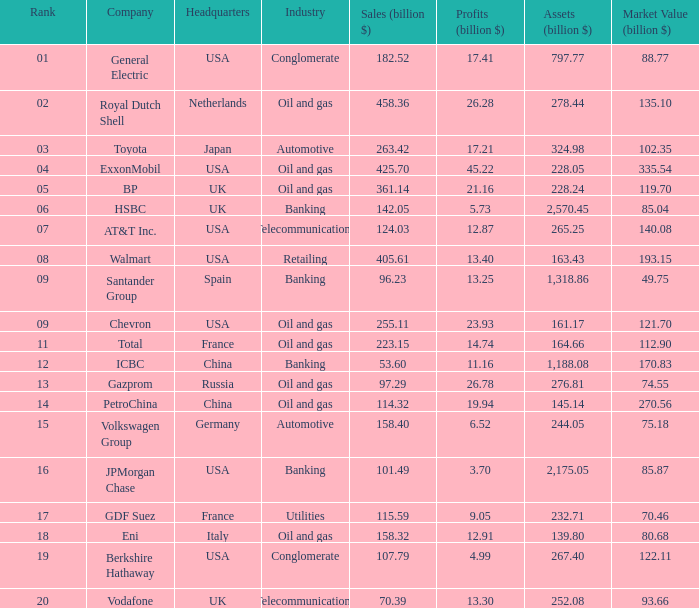Parse the full table. {'header': ['Rank', 'Company', 'Headquarters', 'Industry', 'Sales (billion $)', 'Profits (billion $)', 'Assets (billion $)', 'Market Value (billion $)'], 'rows': [['01', 'General Electric', 'USA', 'Conglomerate', '182.52', '17.41', '797.77', '88.77'], ['02', 'Royal Dutch Shell', 'Netherlands', 'Oil and gas', '458.36', '26.28', '278.44', '135.10'], ['03', 'Toyota', 'Japan', 'Automotive', '263.42', '17.21', '324.98', '102.35'], ['04', 'ExxonMobil', 'USA', 'Oil and gas', '425.70', '45.22', '228.05', '335.54'], ['05', 'BP', 'UK', 'Oil and gas', '361.14', '21.16', '228.24', '119.70'], ['06', 'HSBC', 'UK', 'Banking', '142.05', '5.73', '2,570.45', '85.04'], ['07', 'AT&T Inc.', 'USA', 'Telecommunications', '124.03', '12.87', '265.25', '140.08'], ['08', 'Walmart', 'USA', 'Retailing', '405.61', '13.40', '163.43', '193.15'], ['09', 'Santander Group', 'Spain', 'Banking', '96.23', '13.25', '1,318.86', '49.75'], ['09', 'Chevron', 'USA', 'Oil and gas', '255.11', '23.93', '161.17', '121.70'], ['11', 'Total', 'France', 'Oil and gas', '223.15', '14.74', '164.66', '112.90'], ['12', 'ICBC', 'China', 'Banking', '53.60', '11.16', '1,188.08', '170.83'], ['13', 'Gazprom', 'Russia', 'Oil and gas', '97.29', '26.78', '276.81', '74.55'], ['14', 'PetroChina', 'China', 'Oil and gas', '114.32', '19.94', '145.14', '270.56'], ['15', 'Volkswagen Group', 'Germany', 'Automotive', '158.40', '6.52', '244.05', '75.18'], ['16', 'JPMorgan Chase', 'USA', 'Banking', '101.49', '3.70', '2,175.05', '85.87'], ['17', 'GDF Suez', 'France', 'Utilities', '115.59', '9.05', '232.71', '70.46'], ['18', 'Eni', 'Italy', 'Oil and gas', '158.32', '12.91', '139.80', '80.68'], ['19', 'Berkshire Hathaway', 'USA', 'Conglomerate', '107.79', '4.99', '267.40', '122.11'], ['20', 'Vodafone', 'UK', 'Telecommunications', '70.39', '13.30', '252.08', '93.66']]} Identify the minimum profits (billion $) for a company with 425.7 billion dollars in sales and a ranking higher than 4? None. 